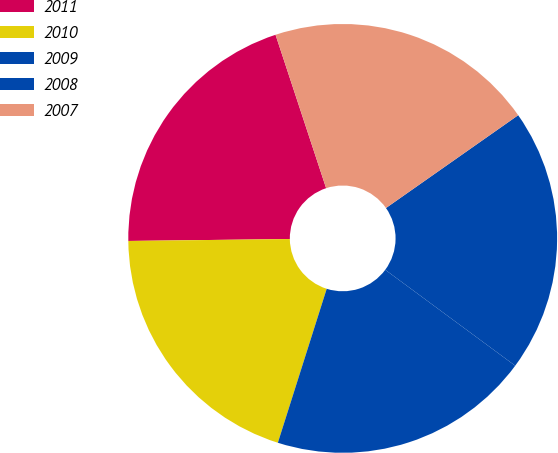Convert chart. <chart><loc_0><loc_0><loc_500><loc_500><pie_chart><fcel>2011<fcel>2010<fcel>2009<fcel>2008<fcel>2007<nl><fcel>20.12%<fcel>19.92%<fcel>19.77%<fcel>19.86%<fcel>20.33%<nl></chart> 